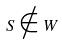Convert formula to latex. <formula><loc_0><loc_0><loc_500><loc_500>S \notin W</formula> 